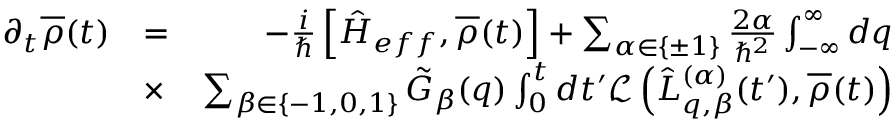<formula> <loc_0><loc_0><loc_500><loc_500>\begin{array} { r l r } { \partial _ { t } \overline { \rho } ( t ) } & { = } & { - \frac { i } { } \left [ \hat { H } _ { e f f } , \overline { \rho } ( t ) \right ] + \sum _ { \alpha \in \{ \pm 1 \} } \frac { 2 \alpha } { \hbar { ^ } { 2 } } \int _ { - \infty } ^ { \infty } d q } \\ & { \times } & { \sum _ { \beta \in \{ - 1 , 0 , 1 \} } \tilde { G } _ { \beta } ( q ) \int _ { 0 } ^ { t } d t ^ { \prime } \mathcal { L } \left ( \hat { L } _ { q , \beta } ^ { ( \alpha ) } ( t ^ { \prime } ) , \overline { \rho } ( t ) \right ) } \end{array}</formula> 